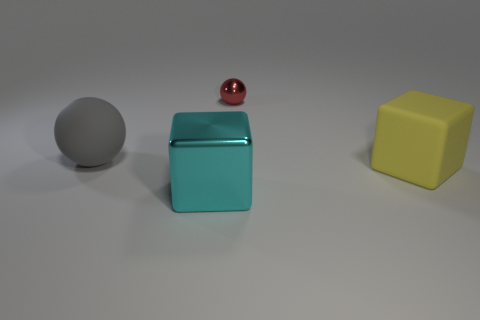There is a block to the left of the yellow object; is its color the same as the rubber thing behind the large yellow rubber block?
Offer a very short reply. No. What is the shape of the matte object that is on the left side of the red sphere?
Give a very brief answer. Sphere. What color is the large rubber cube?
Offer a terse response. Yellow. What is the shape of the big thing that is the same material as the tiny red thing?
Your answer should be very brief. Cube. There is a cube that is to the left of the red metal ball; is it the same size as the red sphere?
Offer a very short reply. No. What number of things are either matte things behind the large yellow rubber thing or big matte objects behind the yellow matte block?
Provide a short and direct response. 1. There is a shiny thing that is behind the yellow rubber block; does it have the same color as the big ball?
Provide a succinct answer. No. How many matte things are small red things or big purple balls?
Provide a short and direct response. 0. What is the shape of the large yellow rubber thing?
Provide a succinct answer. Cube. Are there any other things that are made of the same material as the big yellow block?
Provide a succinct answer. Yes. 